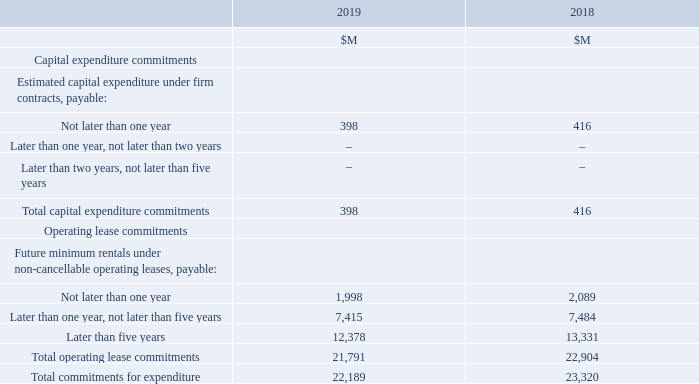This section presents the Group’s contractual obligation to make a payment in the future in relation to purchases of property, plant and equipment, and lease commitments.
Capital expenditure and operating lease commitments of the Group at the reporting date are as follows:
The commitments set out above do not include contingent turnover rentals, which are charged on many retail premises leased by the Group. These rentals are calculated as a percentage of the turnover of the store occupying the premises, with the percentage and turnover threshold at which the additional rentals commence varying with each lease agreement.
The Group leases retail premises and warehousing facilities which are generally for periods up to 40 years. The operating lease commitments include leases for the Norwest office and distribution centres. Generally the lease agreements are for initial terms of between five and 25 years and most include multiple renewal options for additional five to 10-year terms. Under most leases, the Group is responsible for property taxes, insurance, maintenance, and expenses related to the leased properties. However, many of the more recent lease agreements have been negotiated on a gross or semi-gross basis, which eliminates or significantly reduces the Group’s exposure to operational charges associated with the properties.
From 1 July 2019, the Group adopted AASB 16 Leases and as a result the operating lease commitments set out above have been recognised in the Consolidated Statement of Financial Position, with the exception of the service component of lease payments. Refer to Note 1.2.6 for a reconciliation between the operating lease commitments at 30 June 2019 and the lease liabilities recognised at 1 July 2019.
What is the unit used in the table? $m. What is the total commitments for expenditure in 2019?
Answer scale should be: million. 22,189. What establishments do the Group lease? The group leases retail premises and warehousing facilities which are generally for periods up to 40 years. What is the difference in total operating lease commitments between 2018 and 2019?
Answer scale should be: million. 22,904 - 21,791 
Answer: 1113. What is the average total commitments for expenditures for 2018 and 2019?
Answer scale should be: million. (22,189 + 23,320)/2 
Answer: 22754.5. What is the percentage constitution of total capital expenditure commitments in the total commitments for expenditure in 2018?
Answer scale should be: percent. 416/23,320 
Answer: 1.78. 